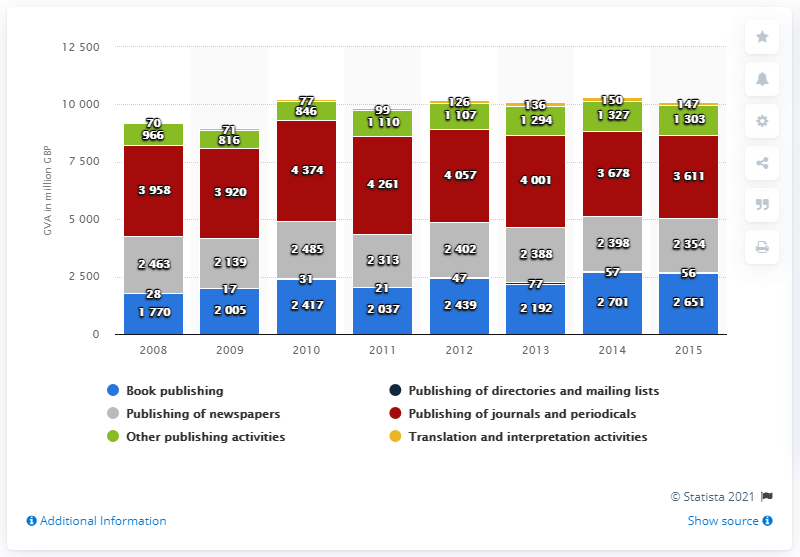Draw attention to some important aspects in this diagram. Gross Value Added (GVA), which represents the value of goods and services produced in a region or economy, was the largest in 2008 at 3958.. The value of the shortest bar is 17. The gross value added for book publishing in 2015 was 2,701. 